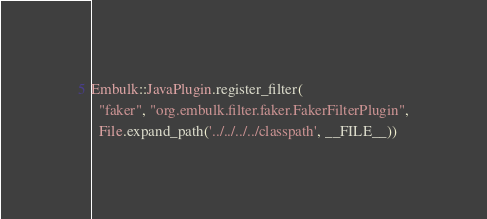<code> <loc_0><loc_0><loc_500><loc_500><_Ruby_>Embulk::JavaPlugin.register_filter(
  "faker", "org.embulk.filter.faker.FakerFilterPlugin",
  File.expand_path('../../../../classpath', __FILE__))
</code> 